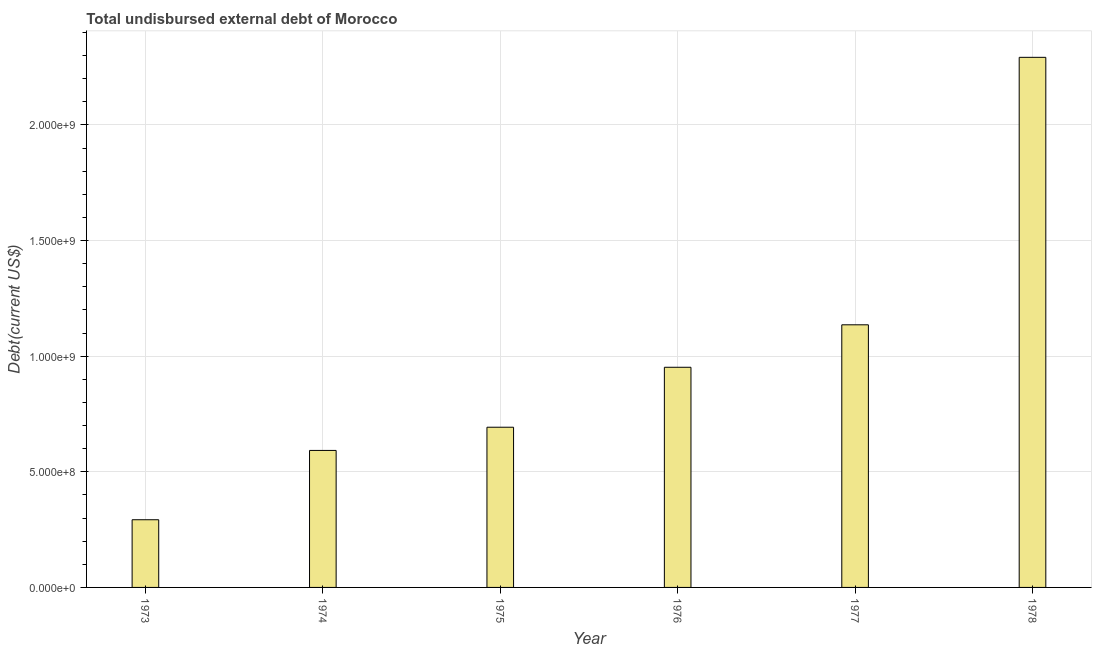Does the graph contain grids?
Offer a terse response. Yes. What is the title of the graph?
Keep it short and to the point. Total undisbursed external debt of Morocco. What is the label or title of the X-axis?
Provide a short and direct response. Year. What is the label or title of the Y-axis?
Offer a terse response. Debt(current US$). What is the total debt in 1973?
Your response must be concise. 2.93e+08. Across all years, what is the maximum total debt?
Keep it short and to the point. 2.29e+09. Across all years, what is the minimum total debt?
Give a very brief answer. 2.93e+08. In which year was the total debt maximum?
Make the answer very short. 1978. What is the sum of the total debt?
Keep it short and to the point. 5.96e+09. What is the difference between the total debt in 1973 and 1977?
Offer a very short reply. -8.43e+08. What is the average total debt per year?
Your answer should be very brief. 9.93e+08. What is the median total debt?
Provide a succinct answer. 8.22e+08. Do a majority of the years between 1975 and 1978 (inclusive) have total debt greater than 300000000 US$?
Give a very brief answer. Yes. What is the ratio of the total debt in 1973 to that in 1977?
Offer a very short reply. 0.26. Is the total debt in 1973 less than that in 1974?
Give a very brief answer. Yes. What is the difference between the highest and the second highest total debt?
Offer a very short reply. 1.16e+09. What is the difference between the highest and the lowest total debt?
Offer a terse response. 2.00e+09. How many bars are there?
Your answer should be compact. 6. What is the difference between two consecutive major ticks on the Y-axis?
Give a very brief answer. 5.00e+08. What is the Debt(current US$) in 1973?
Your response must be concise. 2.93e+08. What is the Debt(current US$) of 1974?
Offer a very short reply. 5.92e+08. What is the Debt(current US$) in 1975?
Ensure brevity in your answer.  6.93e+08. What is the Debt(current US$) in 1976?
Your answer should be compact. 9.52e+08. What is the Debt(current US$) in 1977?
Keep it short and to the point. 1.14e+09. What is the Debt(current US$) in 1978?
Offer a very short reply. 2.29e+09. What is the difference between the Debt(current US$) in 1973 and 1974?
Your answer should be very brief. -3.00e+08. What is the difference between the Debt(current US$) in 1973 and 1975?
Make the answer very short. -4.00e+08. What is the difference between the Debt(current US$) in 1973 and 1976?
Provide a short and direct response. -6.59e+08. What is the difference between the Debt(current US$) in 1973 and 1977?
Your answer should be very brief. -8.43e+08. What is the difference between the Debt(current US$) in 1973 and 1978?
Offer a very short reply. -2.00e+09. What is the difference between the Debt(current US$) in 1974 and 1975?
Your answer should be compact. -1.00e+08. What is the difference between the Debt(current US$) in 1974 and 1976?
Provide a succinct answer. -3.60e+08. What is the difference between the Debt(current US$) in 1974 and 1977?
Ensure brevity in your answer.  -5.43e+08. What is the difference between the Debt(current US$) in 1974 and 1978?
Provide a succinct answer. -1.70e+09. What is the difference between the Debt(current US$) in 1975 and 1976?
Offer a terse response. -2.59e+08. What is the difference between the Debt(current US$) in 1975 and 1977?
Make the answer very short. -4.43e+08. What is the difference between the Debt(current US$) in 1975 and 1978?
Make the answer very short. -1.60e+09. What is the difference between the Debt(current US$) in 1976 and 1977?
Offer a very short reply. -1.84e+08. What is the difference between the Debt(current US$) in 1976 and 1978?
Offer a terse response. -1.34e+09. What is the difference between the Debt(current US$) in 1977 and 1978?
Your answer should be compact. -1.16e+09. What is the ratio of the Debt(current US$) in 1973 to that in 1974?
Make the answer very short. 0.49. What is the ratio of the Debt(current US$) in 1973 to that in 1975?
Provide a short and direct response. 0.42. What is the ratio of the Debt(current US$) in 1973 to that in 1976?
Offer a terse response. 0.31. What is the ratio of the Debt(current US$) in 1973 to that in 1977?
Give a very brief answer. 0.26. What is the ratio of the Debt(current US$) in 1973 to that in 1978?
Ensure brevity in your answer.  0.13. What is the ratio of the Debt(current US$) in 1974 to that in 1975?
Offer a terse response. 0.85. What is the ratio of the Debt(current US$) in 1974 to that in 1976?
Your answer should be very brief. 0.62. What is the ratio of the Debt(current US$) in 1974 to that in 1977?
Offer a terse response. 0.52. What is the ratio of the Debt(current US$) in 1974 to that in 1978?
Provide a short and direct response. 0.26. What is the ratio of the Debt(current US$) in 1975 to that in 1976?
Your answer should be compact. 0.73. What is the ratio of the Debt(current US$) in 1975 to that in 1977?
Give a very brief answer. 0.61. What is the ratio of the Debt(current US$) in 1975 to that in 1978?
Provide a short and direct response. 0.3. What is the ratio of the Debt(current US$) in 1976 to that in 1977?
Keep it short and to the point. 0.84. What is the ratio of the Debt(current US$) in 1976 to that in 1978?
Your response must be concise. 0.41. What is the ratio of the Debt(current US$) in 1977 to that in 1978?
Offer a terse response. 0.49. 